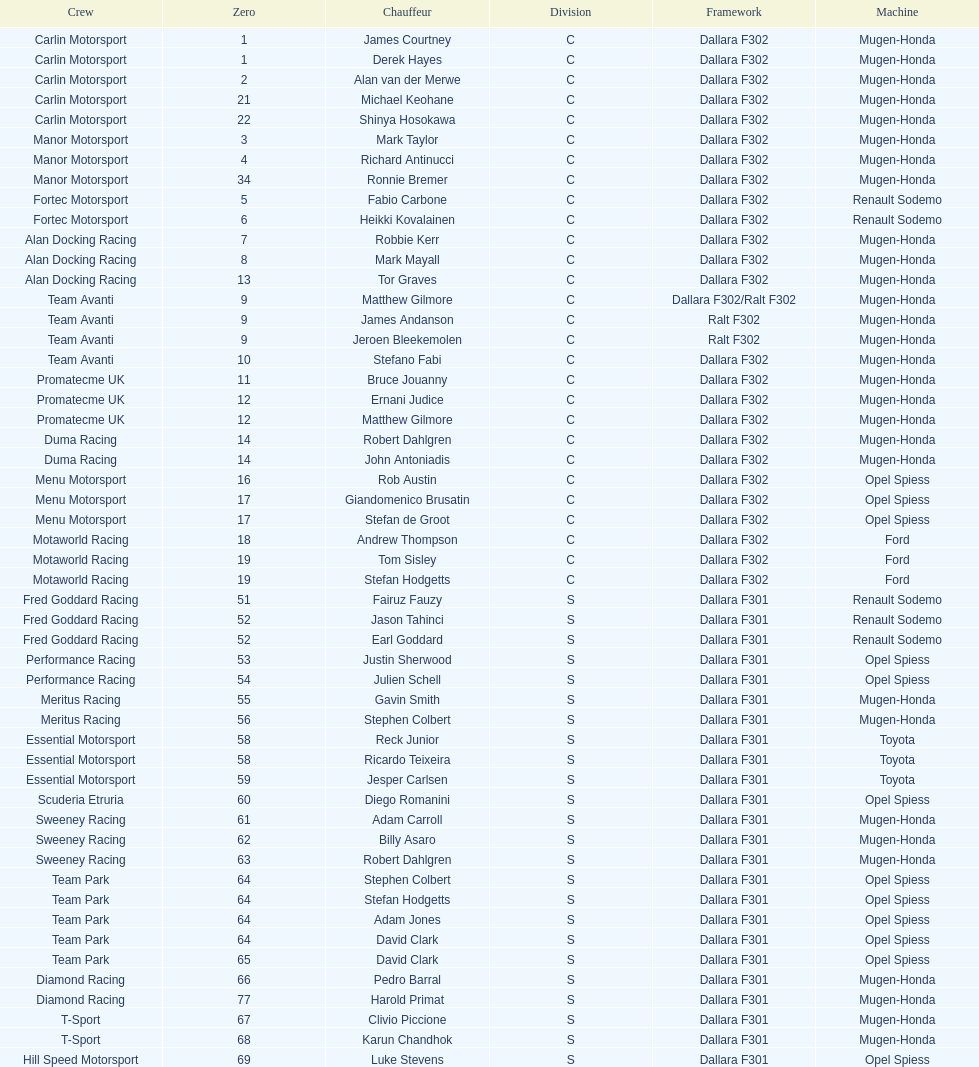What is the total number of class c (championship) teams? 21. 